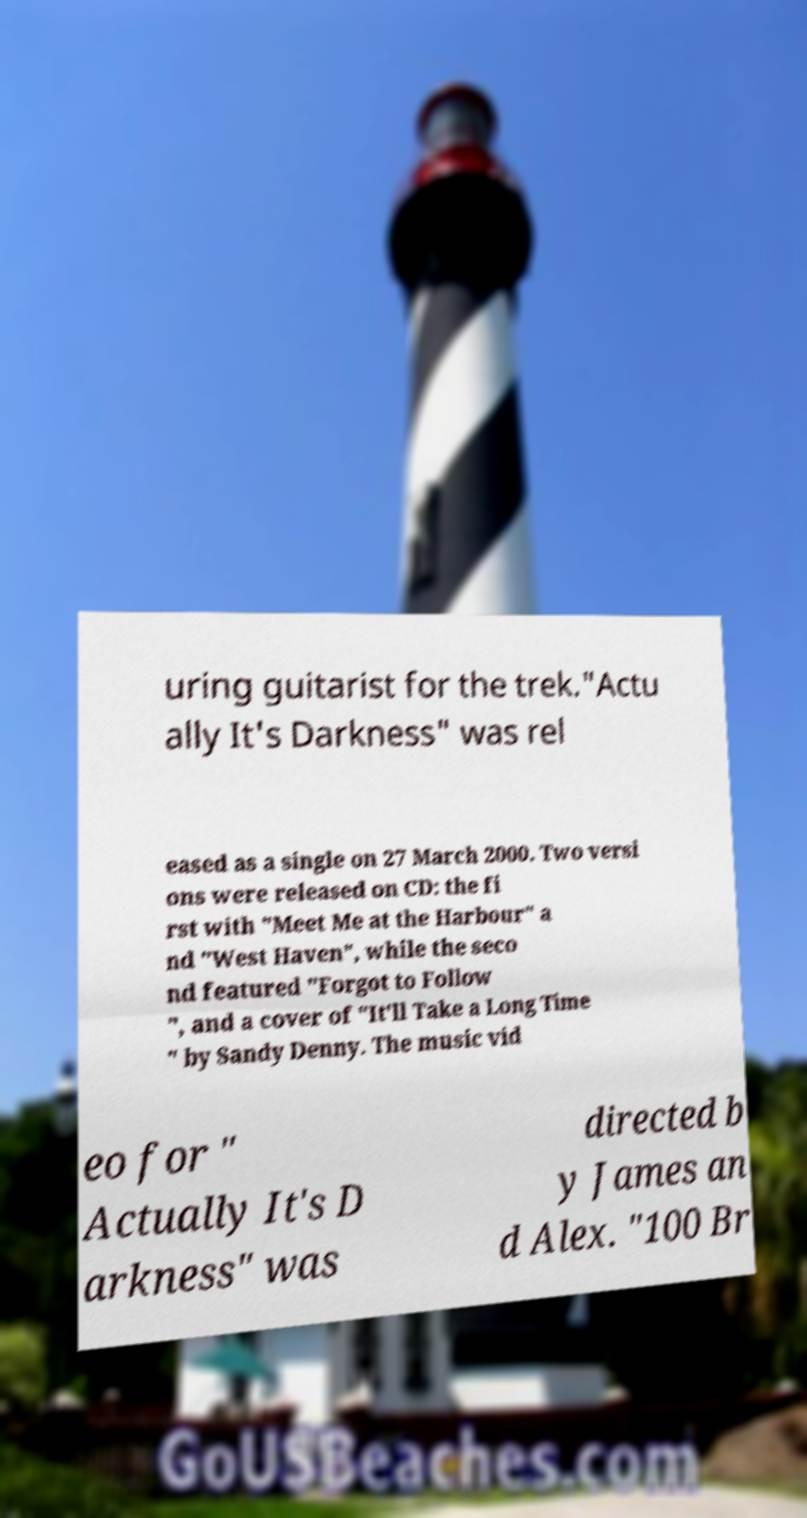There's text embedded in this image that I need extracted. Can you transcribe it verbatim? uring guitarist for the trek."Actu ally It's Darkness" was rel eased as a single on 27 March 2000. Two versi ons were released on CD: the fi rst with "Meet Me at the Harbour" a nd "West Haven", while the seco nd featured "Forgot to Follow ", and a cover of "It'll Take a Long Time " by Sandy Denny. The music vid eo for " Actually It's D arkness" was directed b y James an d Alex. "100 Br 